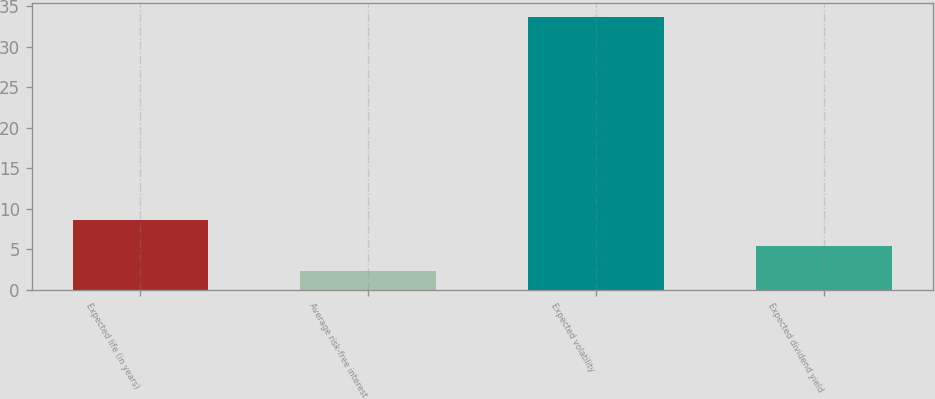Convert chart. <chart><loc_0><loc_0><loc_500><loc_500><bar_chart><fcel>Expected life (in years)<fcel>Average risk-free interest<fcel>Expected volatility<fcel>Expected dividend yield<nl><fcel>8.58<fcel>2.3<fcel>33.7<fcel>5.44<nl></chart> 